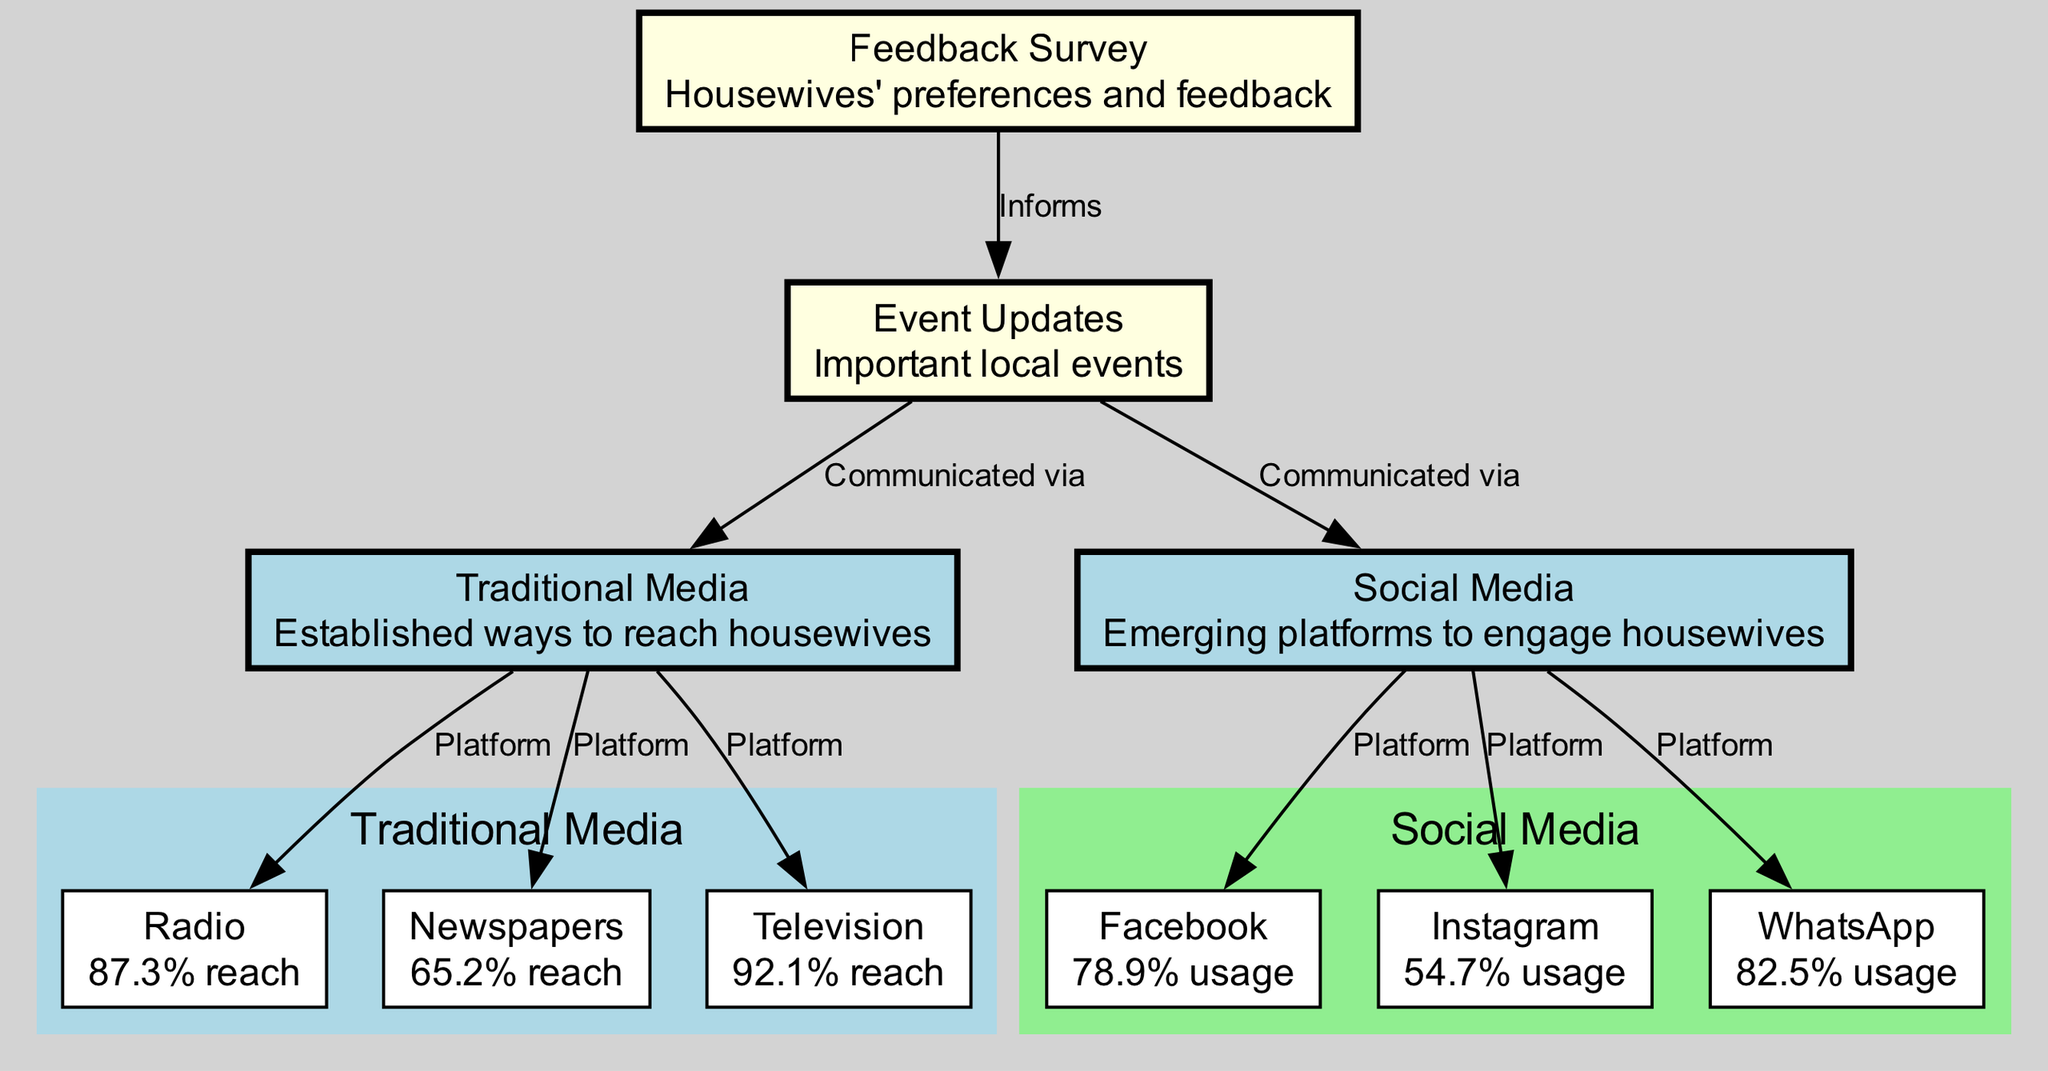What are the three traditional media platforms mentioned? The diagram includes three traditional media platforms: Radio, Newspapers, and Television. They are labeled under the "Traditional Media" cluster.
Answer: Radio, Newspapers, Television What is the reach percentage of television? The diagram explicitly states that Television has a reach of 92.1%, which is shown in its details.
Answer: 92.1% Which social media platform has the highest usage percentage? The diagram lists Facebook as having the highest usage at 78.9%, as indicated in its details.
Answer: Facebook How many edges connect traditional media to other nodes? There are three edges connecting traditional media (Radio, Newspapers, Television) to the "Traditional Media" node, which confirms the number of connections.
Answer: 3 Which platform is used for communicating event updates? The diagram shows that event updates are communicated via both traditional media and social media platforms, as indicated by the connections to the "event_updates" node.
Answer: Traditional Media and Social Media What percentage of housewives use WhatsApp? According to the diagram, WhatsApp has a usage percentage of 82.5%, as noted in its details.
Answer: 82.5% What does the feedback survey inform? The diagram indicates that the feedback survey informs event updates, showing a direct flow from the "feedback_survey" node to the "event_updates" node.
Answer: Event Updates How many platforms are classified under social media in the diagram? The diagram lists three platforms specifically under social media: Facebook, Instagram, and WhatsApp, confirming the count.
Answer: 3 What type of media has more reach, traditional or social? Based on the percentage reach of the traditional media platforms (Radio, Newspapers, Television), it can be deduced that traditional media generally has more reach compared to social media platforms when looking at the specific statistics presented.
Answer: Traditional Media 